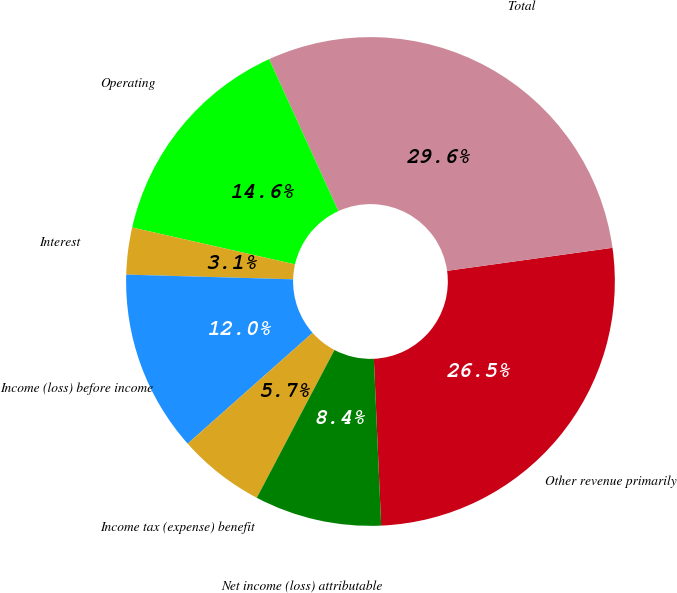Convert chart to OTSL. <chart><loc_0><loc_0><loc_500><loc_500><pie_chart><fcel>Other revenue primarily<fcel>Total<fcel>Operating<fcel>Interest<fcel>Income (loss) before income<fcel>Income tax (expense) benefit<fcel>Net income (loss) attributable<nl><fcel>26.51%<fcel>29.61%<fcel>14.65%<fcel>3.1%<fcel>12.0%<fcel>5.75%<fcel>8.4%<nl></chart> 